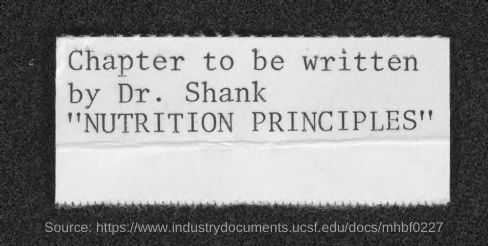Who must write the chapter?
Offer a terse response. Dr. Shank. 